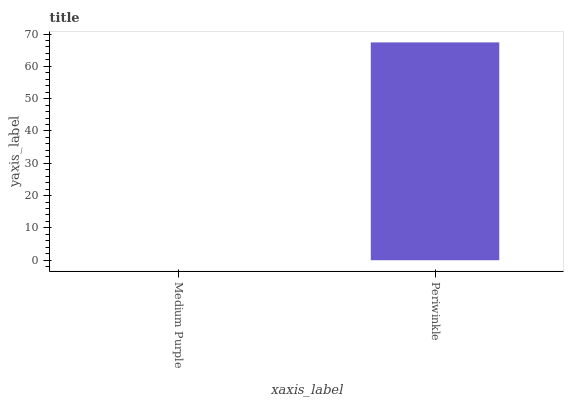Is Medium Purple the minimum?
Answer yes or no. Yes. Is Periwinkle the maximum?
Answer yes or no. Yes. Is Periwinkle the minimum?
Answer yes or no. No. Is Periwinkle greater than Medium Purple?
Answer yes or no. Yes. Is Medium Purple less than Periwinkle?
Answer yes or no. Yes. Is Medium Purple greater than Periwinkle?
Answer yes or no. No. Is Periwinkle less than Medium Purple?
Answer yes or no. No. Is Periwinkle the high median?
Answer yes or no. Yes. Is Medium Purple the low median?
Answer yes or no. Yes. Is Medium Purple the high median?
Answer yes or no. No. Is Periwinkle the low median?
Answer yes or no. No. 